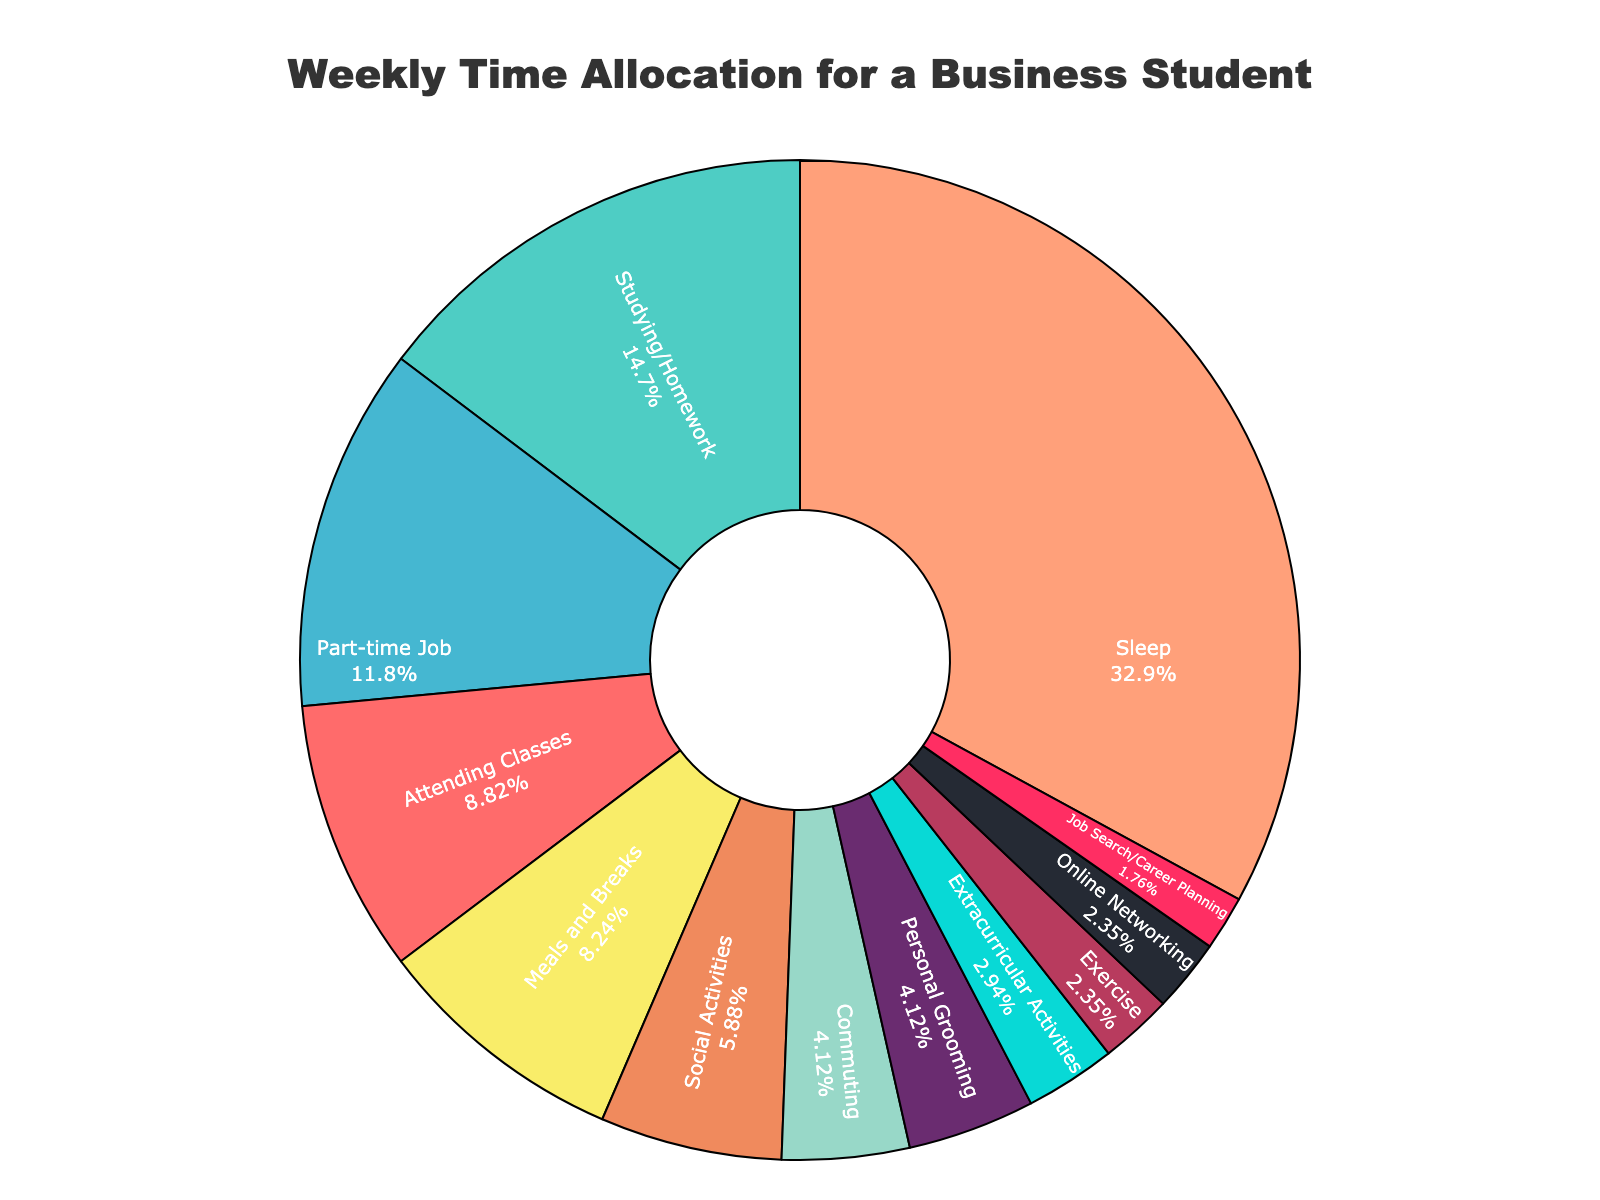What's the largest time allocation activity for a typical business student? The largest time allocation can be identified by the activity segment with the highest percentage on the pie chart. Visually, this is often the largest section.
Answer: Sleep Which two activities combined take up more hours than attending classes? Attending classes takes 15 hours. By inspecting the chart, "Personal Grooming" (7 hours) and "Meals and Breaks" (14 hours) together take 21 hours, which is more than 15 hours.
Answer: Personal Grooming and Meals and Breaks What fraction of the week does studying and homework take? Studying and Homework takes 25 hours out of a total of 168 hours in a week (24 hours * 7 days). The fraction is 25/168. Simplifying the fraction gives 25/168.
Answer: 25/168 What time allocation is less than half the time spent on a part-time job? A part-time job takes 20 hours, so half of that is 10 hours. Activities less than 10 hours include "Social Activities", "Exercise", "Extracurricular Activities", "Online Networking", and "Job Search/Career Planning".
Answer: Social Activities, Exercise, Extracurricular Activities, Online Networking, Job Search/Career Planning How does the time spent on commuting compare to the time spent on meals and breaks? Commuting takes 7 hours, whereas meals and breaks take 14 hours. By comparing these, meals and breaks take twice the time of commuting.
Answer: Meals and breaks take twice as much time What is the combined time allocation for online networking and job search/career planning? Online Networking takes 4 hours, and Job Search/Career Planning takes 3 hours. Adding these together, 4 + 3 = 7 hours.
Answer: 7 hours Which activity occupies the smallest sector of the pie chart? By visually inspecting the pie chart, the smallest sector is "Job Search/Career Planning" with 3 hours.
Answer: Job Search/Career Planning If the total time for three randomly selected activities is 34 hours, which activities could they be? Possible combinations of three activities whose total is 34 hours can be:
1. "Meals and Breaks" (14), "Personal Grooming" (7), and "Exercise" (4) collectively sum to 25 hours. Adding 9 more can be "Online Networking" (4) and "Job Search/Career Planning" (3).
2. There might be other combinations summing to 34 hours.
Answer: Meals and Breaks, Personal Grooming, Exercise, Online Networking, Job Search/Career Planning 